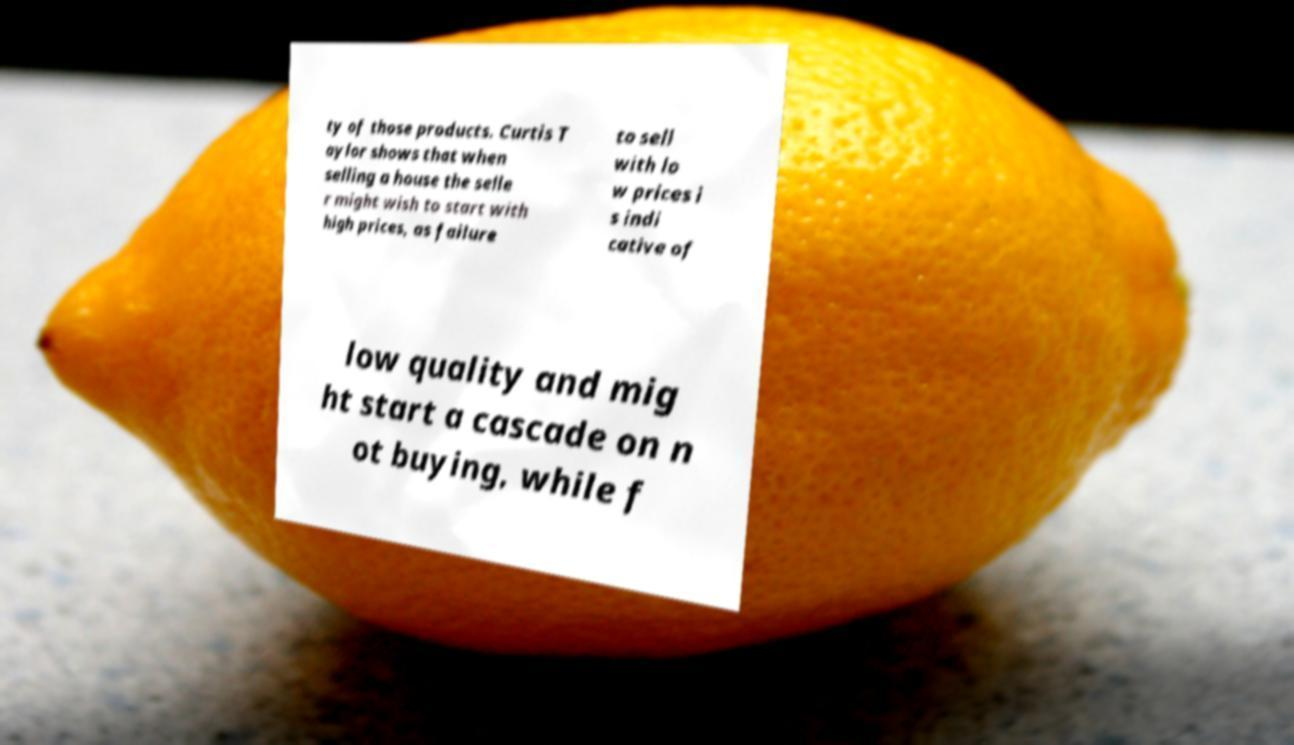Please identify and transcribe the text found in this image. ty of those products. Curtis T aylor shows that when selling a house the selle r might wish to start with high prices, as failure to sell with lo w prices i s indi cative of low quality and mig ht start a cascade on n ot buying, while f 